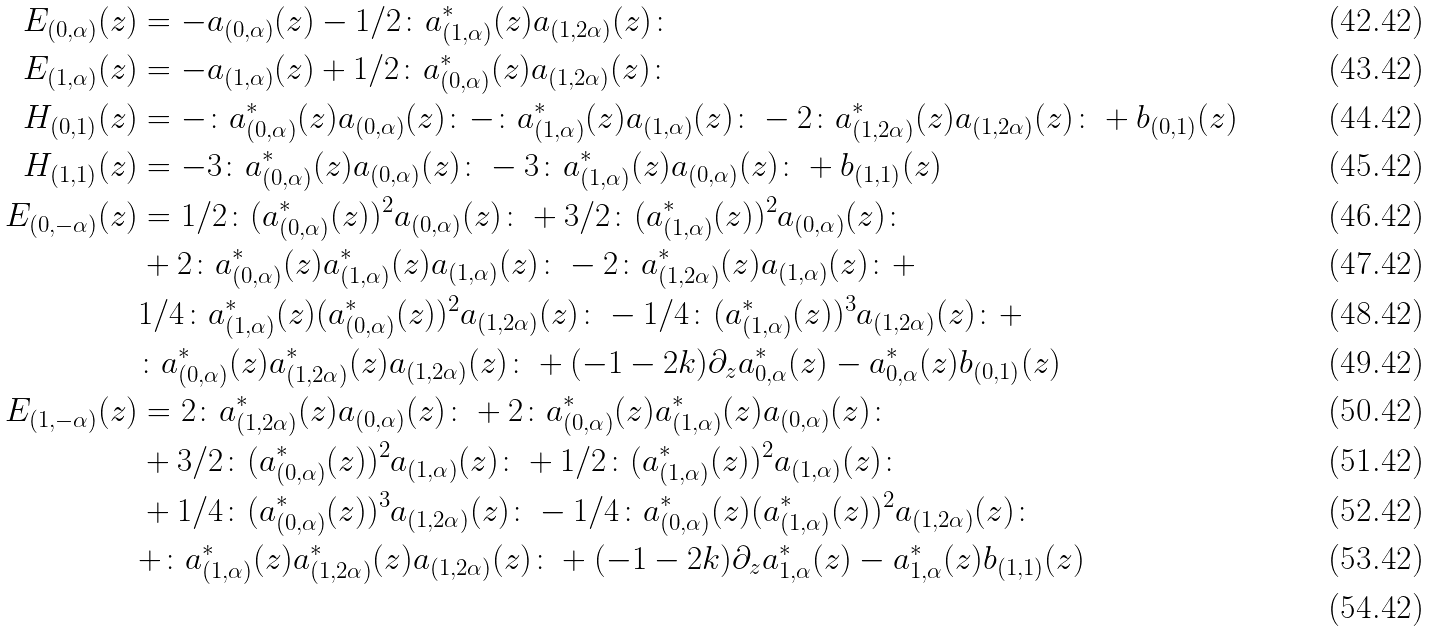Convert formula to latex. <formula><loc_0><loc_0><loc_500><loc_500>E _ { ( 0 , \alpha ) } ( z ) & = - a _ { ( 0 , \alpha ) } ( z ) - 1 / 2 \colon a ^ { * } _ { ( 1 , \alpha ) } ( z ) a _ { ( 1 , 2 \alpha ) } ( z ) \colon \\ E _ { ( 1 , \alpha ) } ( z ) & = - a _ { ( 1 , \alpha ) } ( z ) + 1 / 2 \colon a ^ { * } _ { ( 0 , \alpha ) } ( z ) a _ { ( 1 , 2 \alpha ) } ( z ) \colon \\ H _ { ( 0 , 1 ) } ( z ) & = - \colon a ^ { * } _ { ( 0 , \alpha ) } ( z ) a _ { ( 0 , \alpha ) } ( z ) \colon - \colon a ^ { * } _ { ( 1 , \alpha ) } ( z ) a _ { ( 1 , \alpha ) } ( z ) \colon - 2 \colon a ^ { * } _ { ( 1 , 2 \alpha ) } ( z ) a _ { ( 1 , 2 \alpha ) } ( z ) \colon + b _ { ( 0 , 1 ) } ( z ) \\ H _ { ( 1 , 1 ) } ( z ) & = - 3 \colon a ^ { * } _ { ( 0 , \alpha ) } ( z ) a _ { ( 0 , \alpha ) } ( z ) \colon - 3 \colon a ^ { * } _ { ( 1 , \alpha ) } ( z ) a _ { ( 0 , \alpha ) } ( z ) \colon + b _ { ( 1 , 1 ) } ( z ) \\ E _ { ( 0 , - \alpha ) } ( z ) & = 1 / 2 \colon ( a ^ { * } _ { ( 0 , \alpha ) } ( z ) ) ^ { 2 } a _ { ( 0 , \alpha ) } ( z ) \colon + 3 / 2 \colon ( a ^ { * } _ { ( 1 , \alpha ) } ( z ) ) ^ { 2 } a _ { ( 0 , \alpha ) } ( z ) \colon \\ & + 2 \colon a ^ { * } _ { ( 0 , \alpha ) } ( z ) a ^ { * } _ { ( 1 , \alpha ) } ( z ) a _ { ( 1 , \alpha ) } ( z ) \colon - 2 \colon a ^ { * } _ { ( 1 , 2 \alpha ) } ( z ) a _ { ( 1 , \alpha ) } ( z ) \colon + \\ & 1 / 4 \colon a ^ { * } _ { ( 1 , \alpha ) } ( z ) ( a ^ { * } _ { ( 0 , \alpha ) } ( z ) ) ^ { 2 } a _ { ( 1 , 2 \alpha ) } ( z ) \colon - 1 / 4 \colon ( a ^ { * } _ { ( 1 , \alpha ) } ( z ) ) ^ { 3 } a _ { ( 1 , 2 \alpha ) } ( z ) \colon + \\ & \colon a ^ { * } _ { ( 0 , \alpha ) } ( z ) a ^ { * } _ { ( 1 , 2 \alpha ) } ( z ) a _ { ( 1 , 2 \alpha ) } ( z ) \colon + ( - 1 - 2 k ) \partial _ { z } a ^ { * } _ { 0 , \alpha } ( z ) - a ^ { * } _ { 0 , \alpha } ( z ) b _ { ( 0 , 1 ) } ( z ) \\ E _ { ( 1 , - \alpha ) } ( z ) & = 2 \colon a ^ { * } _ { ( 1 , 2 \alpha ) } ( z ) a _ { ( 0 , \alpha ) } ( z ) \colon + 2 \colon a ^ { * } _ { ( 0 , \alpha ) } ( z ) a ^ { * } _ { ( 1 , \alpha ) } ( z ) a _ { ( 0 , \alpha ) } ( z ) \colon \\ & + 3 / 2 \colon ( a ^ { * } _ { ( 0 , \alpha ) } ( z ) ) ^ { 2 } a _ { ( 1 , \alpha ) } ( z ) \colon + 1 / 2 \colon ( a ^ { * } _ { ( 1 , \alpha ) } ( z ) ) ^ { 2 } a _ { ( 1 , \alpha ) } ( z ) \colon \\ & + 1 / 4 \colon ( a ^ { * } _ { ( 0 , \alpha ) } ( z ) ) ^ { 3 } a _ { ( 1 , 2 \alpha ) } ( z ) \colon - 1 / 4 \colon a ^ { * } _ { ( 0 , \alpha ) } ( z ) ( a ^ { * } _ { ( 1 , \alpha ) } ( z ) ) ^ { 2 } a _ { ( 1 , 2 \alpha ) } ( z ) \colon \\ & + \colon a ^ { * } _ { ( 1 , \alpha ) } ( z ) a ^ { * } _ { ( 1 , 2 \alpha ) } ( z ) a _ { ( 1 , 2 \alpha ) } ( z ) \colon + ( - 1 - 2 k ) \partial _ { z } a ^ { * } _ { 1 , \alpha } ( z ) - a ^ { * } _ { 1 , \alpha } ( z ) b _ { ( 1 , 1 ) } ( z ) \\</formula> 